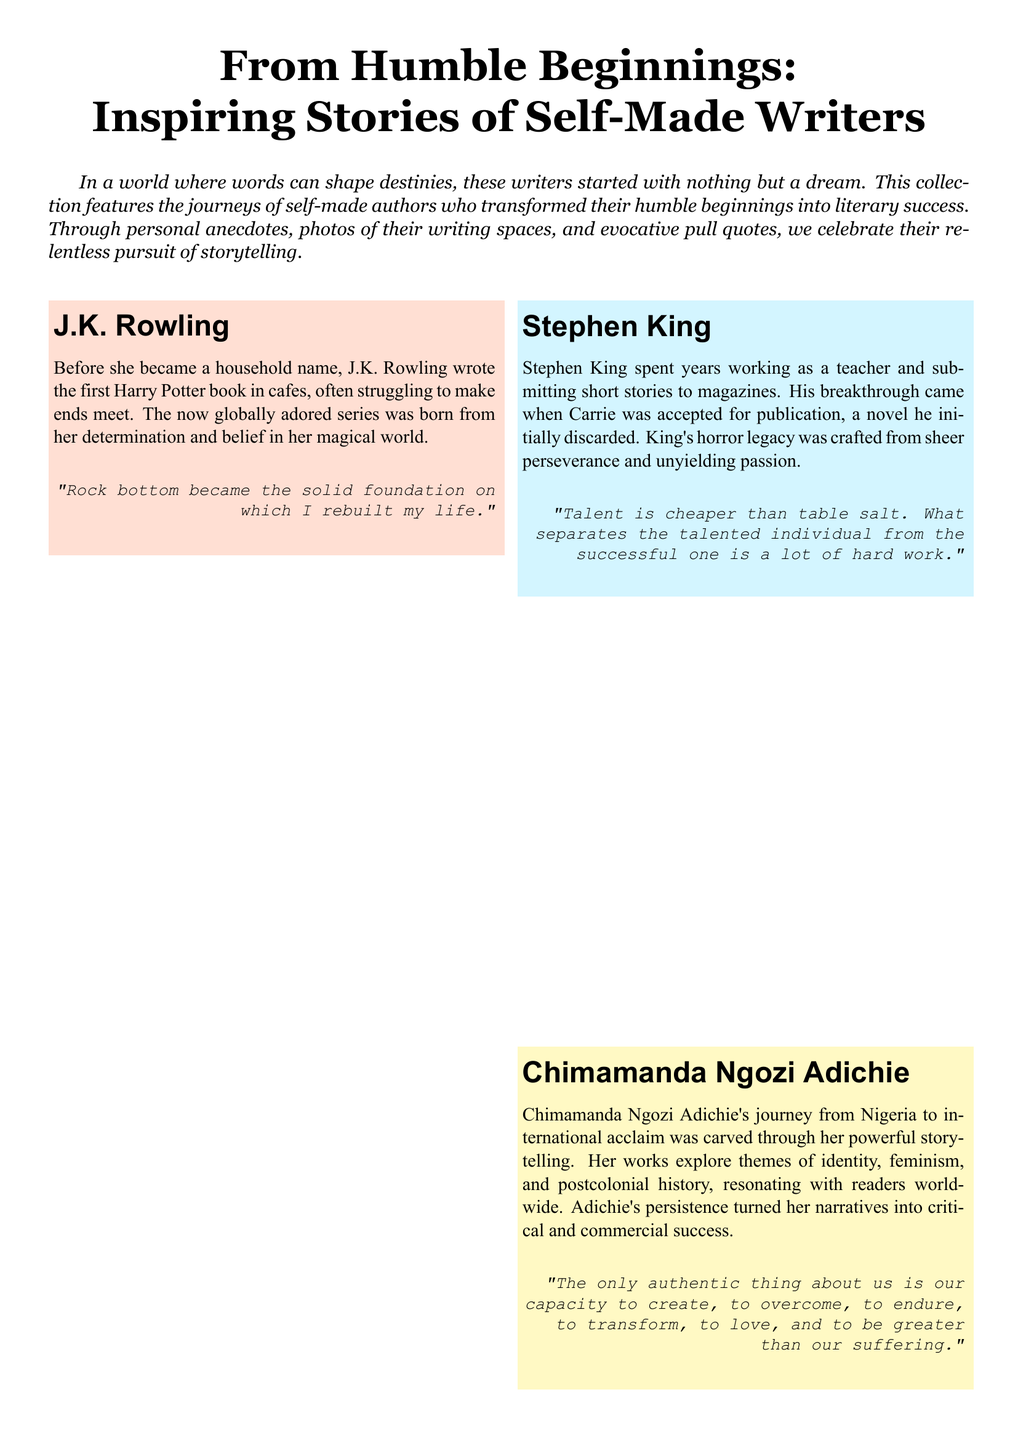What is the title of the magazine section? The title is the main heading that introduces the content of the section, which is "From Humble Beginnings: Inspiring Stories of Self-Made Writers."
Answer: From Humble Beginnings: Inspiring Stories of Self-Made Writers How many writers are featured in the document? The document includes four distinct profiles of writers, showcasing their journeys.
Answer: Four writers Which writer is associated with the color code #FFDFD3? The color code corresponds to the background of the writer's box for J.K. Rowling.
Answer: J.K. Rowling What profession did Stephen King have before his breakthrough? The document states that he worked as a teacher prior to achieving success with his writing.
Answer: Teacher Which quote highlights the importance of hard work? The quote reflects on how talent alone is insufficient without effort as mentioned in Stephen King's profile.
Answer: Talent is cheaper than table salt. What separates the talented individual from the successful one is a lot of hard work What common theme connects the featured writers' backgrounds? The document presents a theme of perseverance and transformation from humble beginnings to success.
Answer: Perseverance Which writer wrote about themes of identity and feminism? The specific writer who explores these themes in her works is Chimamanda Ngozi Adichie.
Answer: Chimamanda Ngozi Adichie What type of anecdotes are included in the document? The section includes personal anecdotes that shed light on each writer's unique journey to success.
Answer: Personal anecdotes What typeface is used for the writer's names in the document? The specific font used for the names of the writers is Arial, as stated in the code.
Answer: Arial 